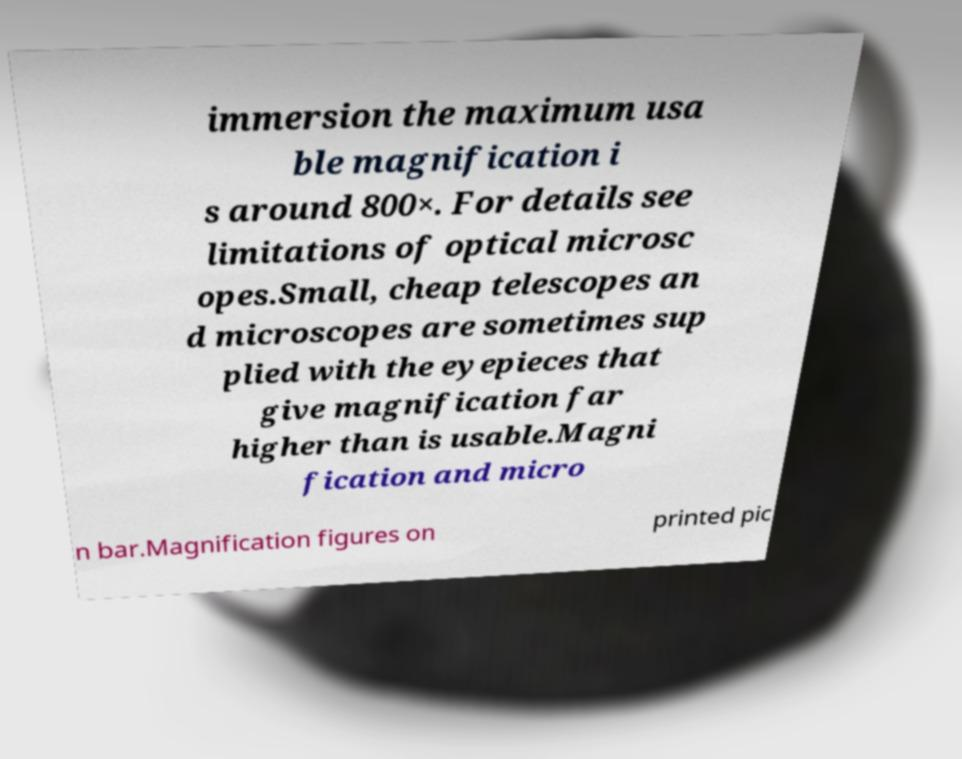Can you accurately transcribe the text from the provided image for me? immersion the maximum usa ble magnification i s around 800×. For details see limitations of optical microsc opes.Small, cheap telescopes an d microscopes are sometimes sup plied with the eyepieces that give magnification far higher than is usable.Magni fication and micro n bar.Magnification figures on printed pic 